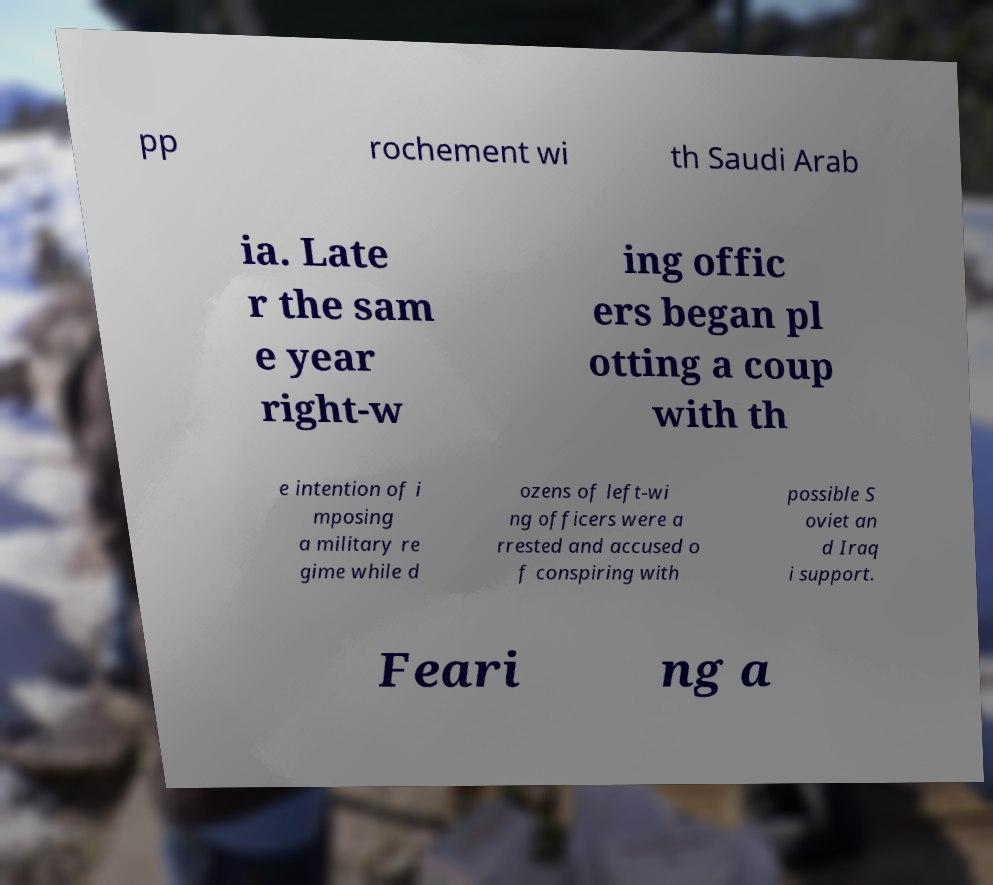For documentation purposes, I need the text within this image transcribed. Could you provide that? pp rochement wi th Saudi Arab ia. Late r the sam e year right-w ing offic ers began pl otting a coup with th e intention of i mposing a military re gime while d ozens of left-wi ng officers were a rrested and accused o f conspiring with possible S oviet an d Iraq i support. Feari ng a 